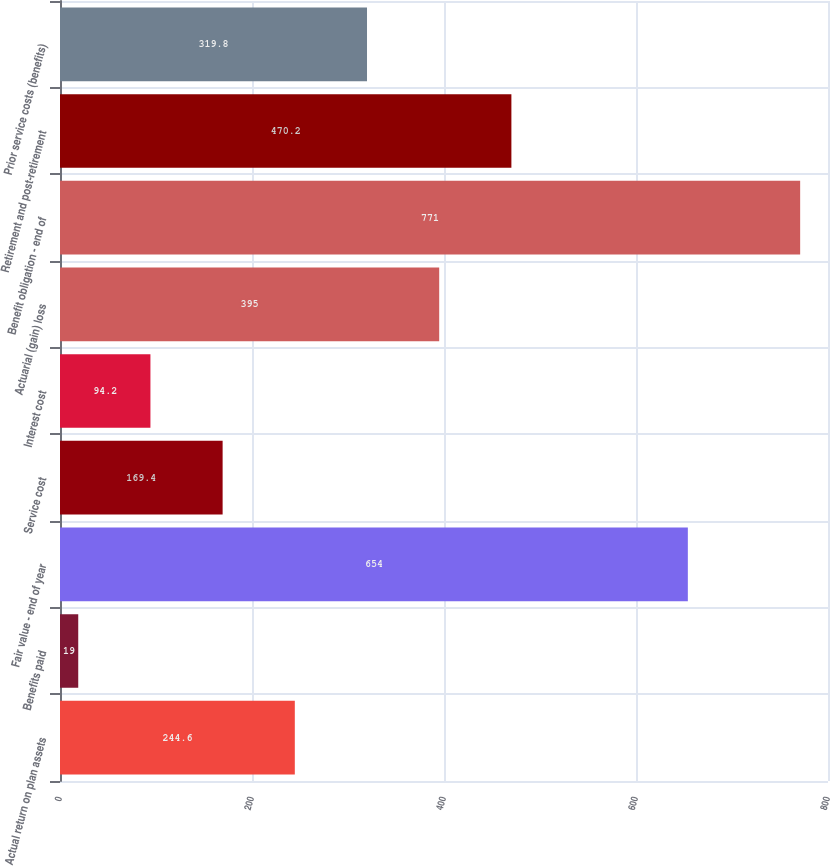<chart> <loc_0><loc_0><loc_500><loc_500><bar_chart><fcel>Actual return on plan assets<fcel>Benefits paid<fcel>Fair value - end of year<fcel>Service cost<fcel>Interest cost<fcel>Actuarial (gain) loss<fcel>Benefit obligation - end of<fcel>Retirement and post-retirement<fcel>Prior service costs (benefits)<nl><fcel>244.6<fcel>19<fcel>654<fcel>169.4<fcel>94.2<fcel>395<fcel>771<fcel>470.2<fcel>319.8<nl></chart> 